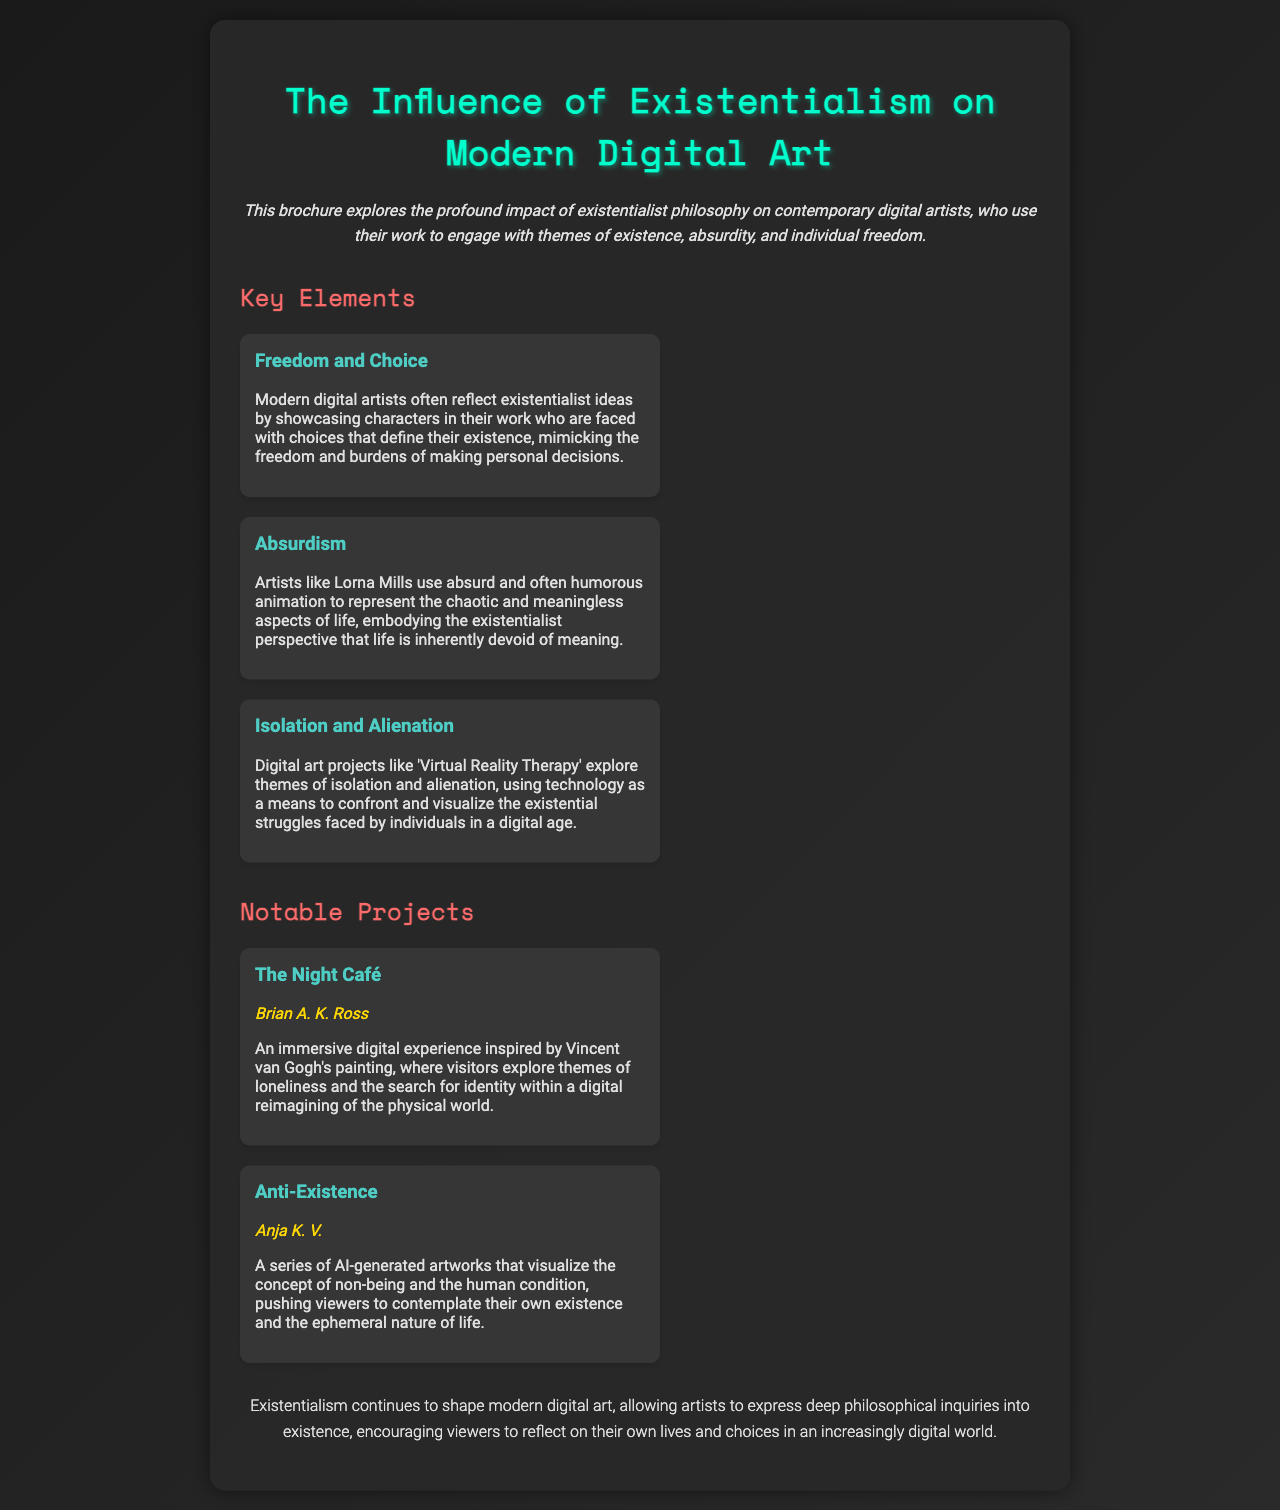What is the title of the brochure? The title of the brochure, prominently displayed at the top, is "The Influence of Existentialism on Modern Digital Art."
Answer: The Influence of Existentialism on Modern Digital Art Who is the artist of "The Night Café"? The artist mentioned in the brochure for "The Night Café" is Brian A. K. Ross.
Answer: Brian A. K. Ross What philosophical theme do modern digital artists often reflect? Modern digital artists often reflect the existentialist theme of freedom and choice, as mentioned in the key elements.
Answer: Freedom and Choice What technique does Lorna Mills use in her art? The document states that Lorna Mills uses absurd and often humorous animation.
Answer: Absurd and humorous animation How does "Virtual Reality Therapy" relate to existentialism? "Virtual Reality Therapy" explores themes of isolation and alienation, tying back to existentialist ideas of individual struggles.
Answer: Isolation and Alienation What does the project "Anti-Existence" visualize? "Anti-Existence" visualizes the concept of non-being and the human condition.
Answer: Non-being and the human condition What is the conclusion about the influence of existentialism on digital art? The conclusion highlights that existentialism allows artists to express deep philosophical inquiries into existence.
Answer: Deep philosophical inquiries into existence What color is used for the section headings? The section headings in the brochure are colored in a shade of red, specifically #ff6b6b.
Answer: Red (#ff6b6b) What narrative style characterizes the introduction? The introduction is characterized by an italicized narrative style.
Answer: Italicized narrative style 